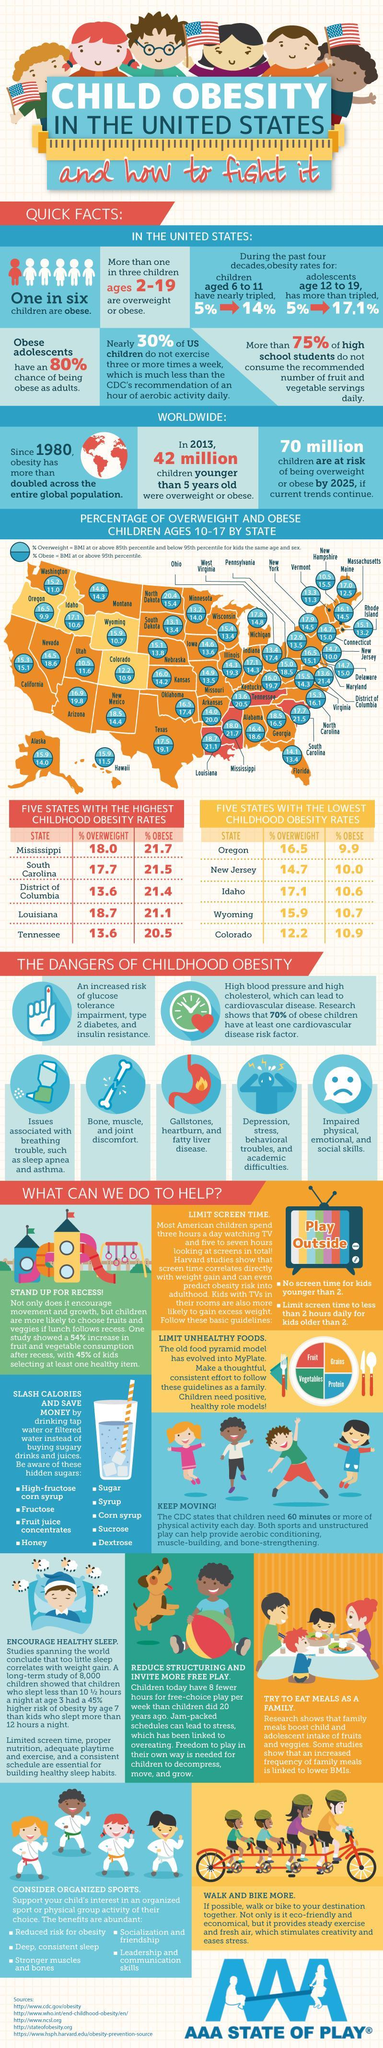What is the percentage of overweight children aged 10-17 in Virginia?
Answer the question with a short phrase. 15.5 What is the percentage of overweight children aged 10-17 in New York? 17.9 What is the percentage of overweight children aged 10-17 in Iowa? 14.6 What is the percentage of obese children aged 10-17 in Texas? 19.1 What is the percentage of obese children aged 10-17 in Minnesota? 14.0 What is the increase in obesity rates in children aged 6-11 in the past four decades? 9% Which state has the lowest percentage of obese children aged 10-17? Oregon Which state has the highest percentage of obese children aged 10-17? Mississippi What is the percentage of obese children aged 10-17 in Virginia? 14.3 What is the increase in obesity rates in adolescents aged 12-19 in the past four decades? 12.1% Which state has the highest percentage of overweight children aged 10-17? North Dakota What is the percentage of overweight children aged 10-17 in Colorado? 12.2 Which state has the second highest percentage of obese children aged 10-17? South Carolina Which state has the second lowest percentage of obese children aged 10-17? New Jersey Which state has the second highest percentage of overweight children aged 10-17? Louisiana What is the percentage of obese children aged 10-17 in California? 15.1 